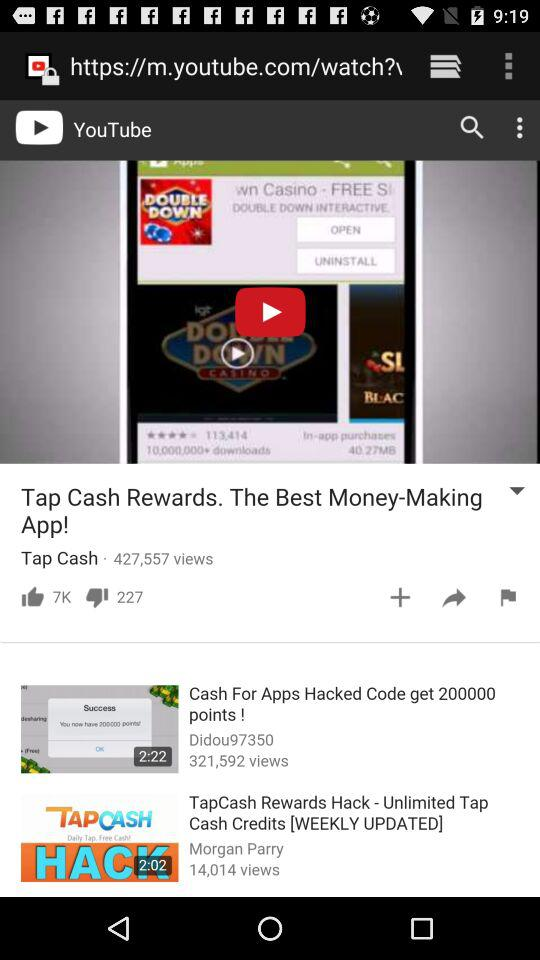How many thumbs down does the video have?
Answer the question using a single word or phrase. 227 